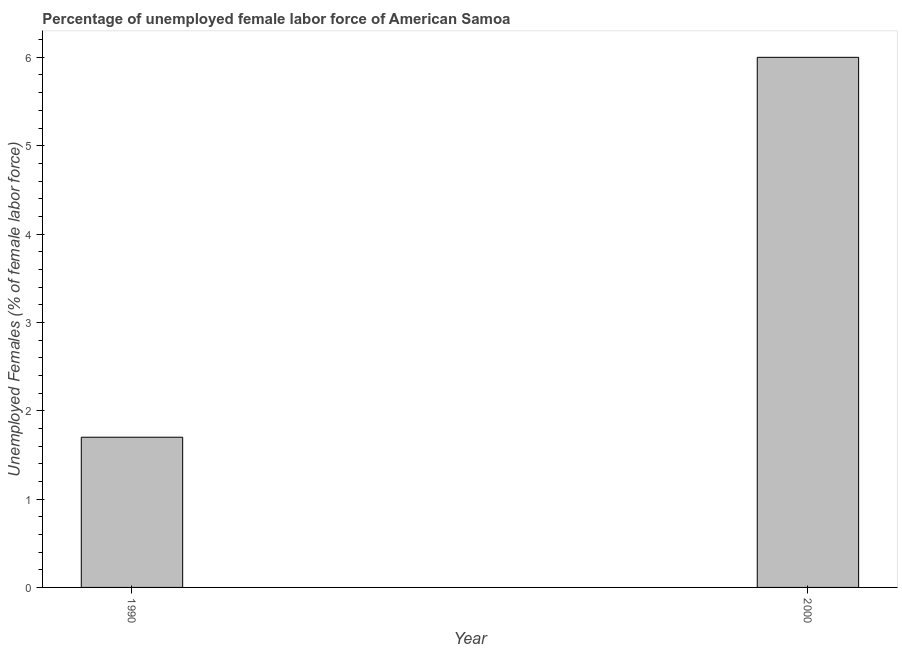Does the graph contain any zero values?
Your answer should be very brief. No. Does the graph contain grids?
Your response must be concise. No. What is the title of the graph?
Your response must be concise. Percentage of unemployed female labor force of American Samoa. What is the label or title of the X-axis?
Keep it short and to the point. Year. What is the label or title of the Y-axis?
Make the answer very short. Unemployed Females (% of female labor force). What is the total unemployed female labour force in 1990?
Your answer should be very brief. 1.7. Across all years, what is the minimum total unemployed female labour force?
Offer a very short reply. 1.7. In which year was the total unemployed female labour force maximum?
Your answer should be compact. 2000. What is the sum of the total unemployed female labour force?
Your answer should be very brief. 7.7. What is the difference between the total unemployed female labour force in 1990 and 2000?
Offer a terse response. -4.3. What is the average total unemployed female labour force per year?
Offer a very short reply. 3.85. What is the median total unemployed female labour force?
Provide a short and direct response. 3.85. Do a majority of the years between 1990 and 2000 (inclusive) have total unemployed female labour force greater than 3.2 %?
Make the answer very short. No. What is the ratio of the total unemployed female labour force in 1990 to that in 2000?
Give a very brief answer. 0.28. Is the total unemployed female labour force in 1990 less than that in 2000?
Provide a short and direct response. Yes. In how many years, is the total unemployed female labour force greater than the average total unemployed female labour force taken over all years?
Offer a terse response. 1. Are all the bars in the graph horizontal?
Offer a terse response. No. How many years are there in the graph?
Ensure brevity in your answer.  2. What is the difference between two consecutive major ticks on the Y-axis?
Offer a terse response. 1. What is the Unemployed Females (% of female labor force) in 1990?
Ensure brevity in your answer.  1.7. What is the difference between the Unemployed Females (% of female labor force) in 1990 and 2000?
Your answer should be compact. -4.3. What is the ratio of the Unemployed Females (% of female labor force) in 1990 to that in 2000?
Offer a terse response. 0.28. 